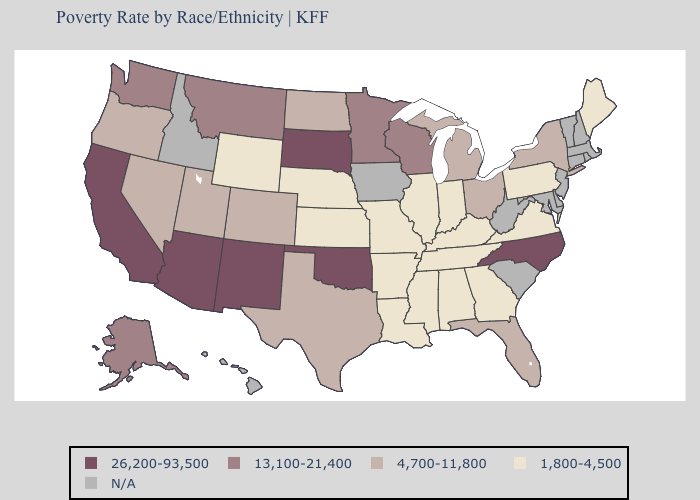Name the states that have a value in the range 26,200-93,500?
Write a very short answer. Arizona, California, New Mexico, North Carolina, Oklahoma, South Dakota. Name the states that have a value in the range 1,800-4,500?
Quick response, please. Alabama, Arkansas, Georgia, Illinois, Indiana, Kansas, Kentucky, Louisiana, Maine, Mississippi, Missouri, Nebraska, Pennsylvania, Tennessee, Virginia, Wyoming. What is the value of Michigan?
Write a very short answer. 4,700-11,800. Among the states that border Illinois , does Wisconsin have the highest value?
Keep it brief. Yes. What is the value of Vermont?
Answer briefly. N/A. Name the states that have a value in the range 26,200-93,500?
Write a very short answer. Arizona, California, New Mexico, North Carolina, Oklahoma, South Dakota. What is the lowest value in the South?
Quick response, please. 1,800-4,500. What is the highest value in states that border Tennessee?
Keep it brief. 26,200-93,500. Name the states that have a value in the range 13,100-21,400?
Write a very short answer. Alaska, Minnesota, Montana, Washington, Wisconsin. Which states have the lowest value in the USA?
Concise answer only. Alabama, Arkansas, Georgia, Illinois, Indiana, Kansas, Kentucky, Louisiana, Maine, Mississippi, Missouri, Nebraska, Pennsylvania, Tennessee, Virginia, Wyoming. What is the lowest value in states that border Montana?
Be succinct. 1,800-4,500. Does the map have missing data?
Answer briefly. Yes. What is the value of West Virginia?
Answer briefly. N/A. Does Nevada have the highest value in the West?
Short answer required. No. Name the states that have a value in the range 4,700-11,800?
Be succinct. Colorado, Florida, Michigan, Nevada, New York, North Dakota, Ohio, Oregon, Texas, Utah. 